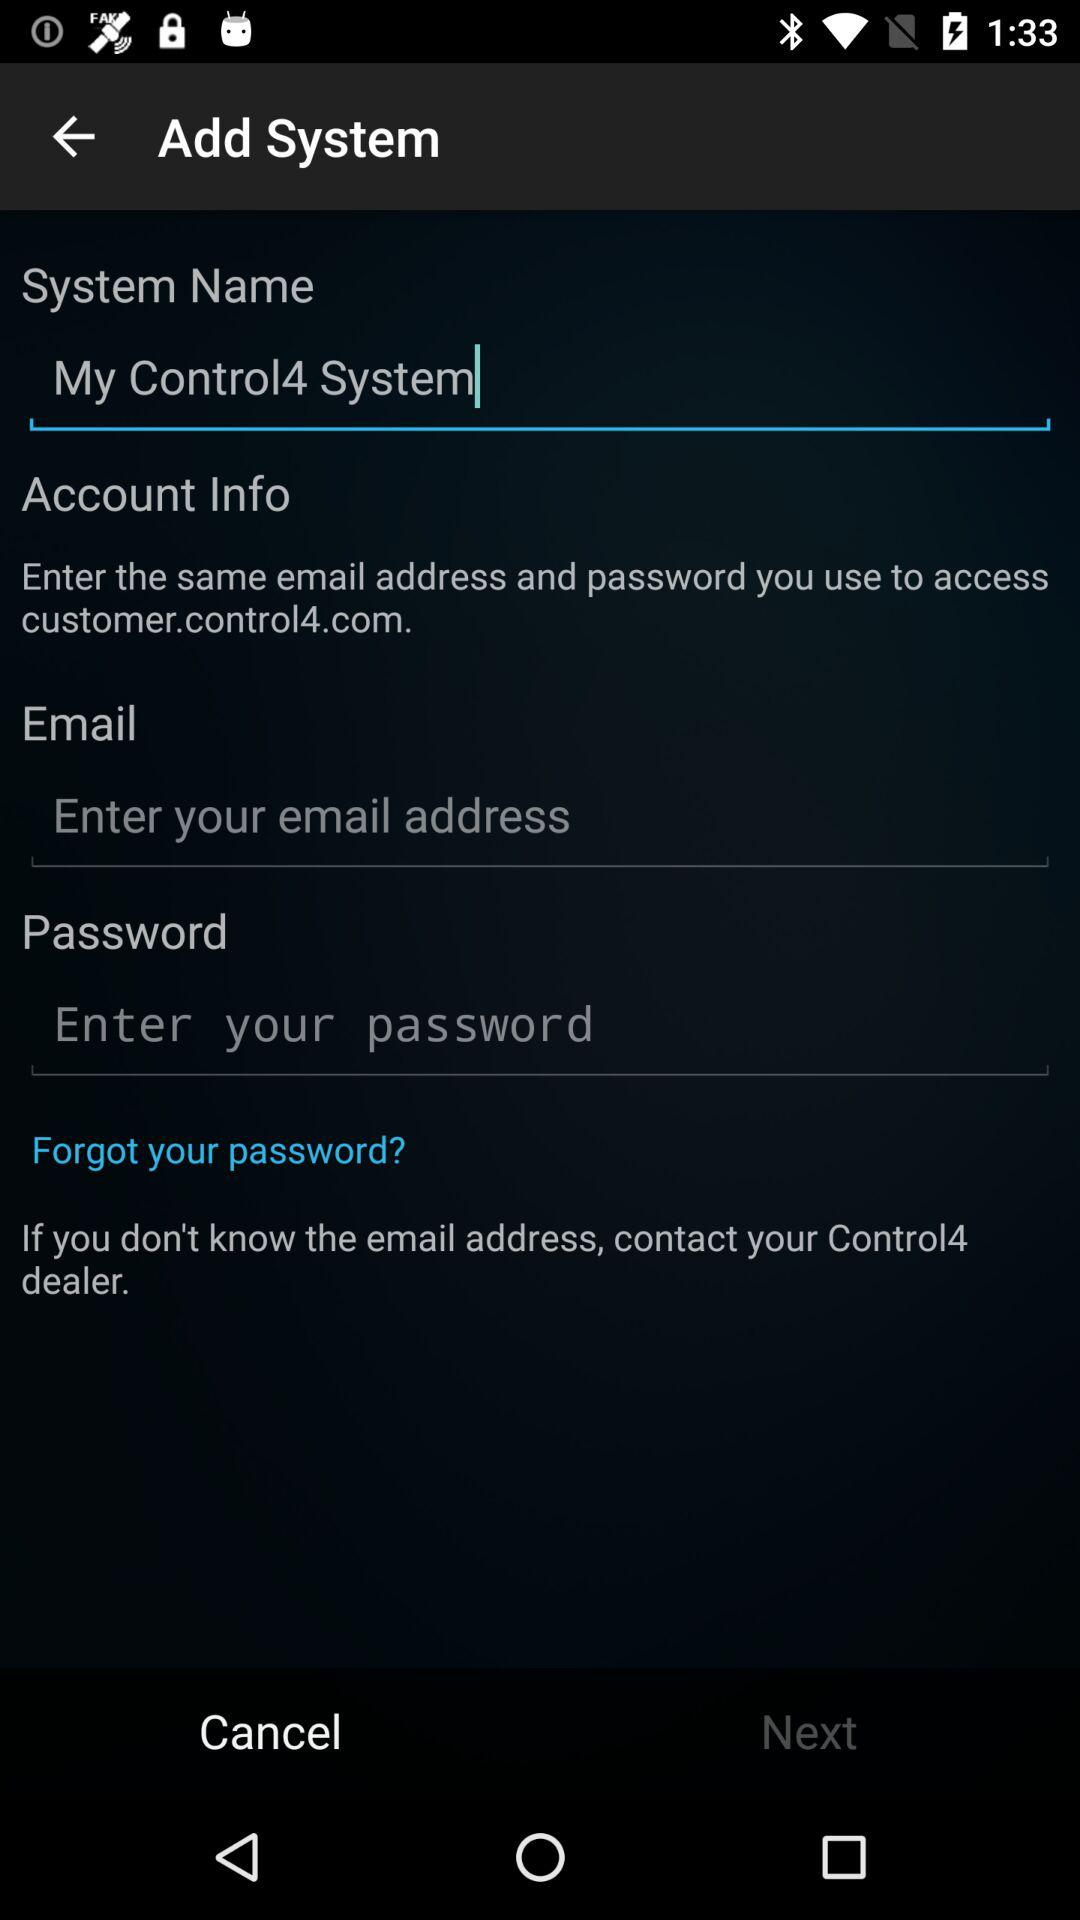Who do I contact if I don't know my password?
When the provided information is insufficient, respond with <no answer>. <no answer> 